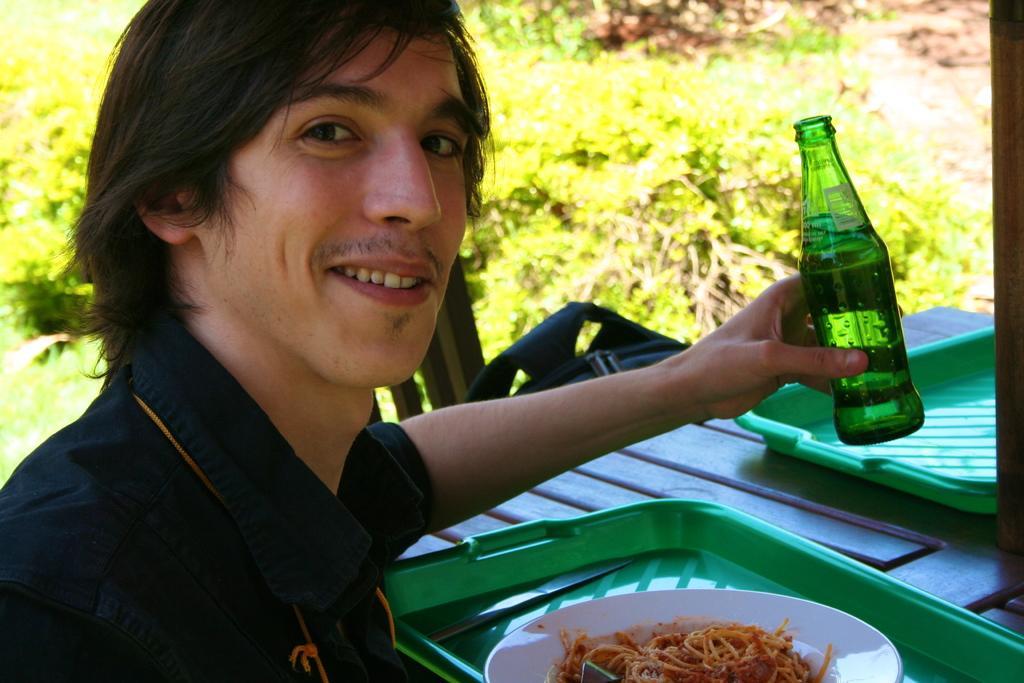Please provide a concise description of this image. The person wearing black shirt is sitting and holding a sprite bottle in his hand and there is a table in front of him which has some eatables on it and there are trees in the background. 